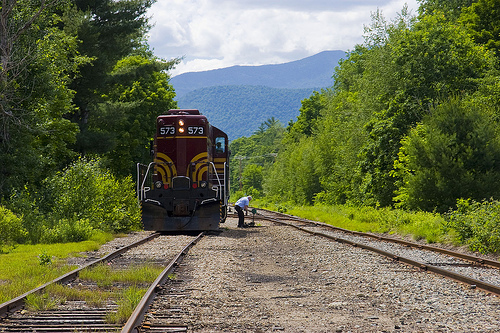<image>
Is there a train to the left of the man? Yes. From this viewpoint, the train is positioned to the left side relative to the man. 